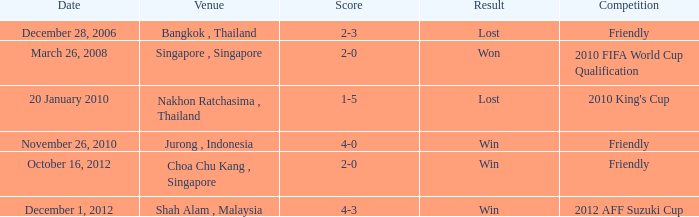Specify the date for a score of 1-5 20 January 2010. 